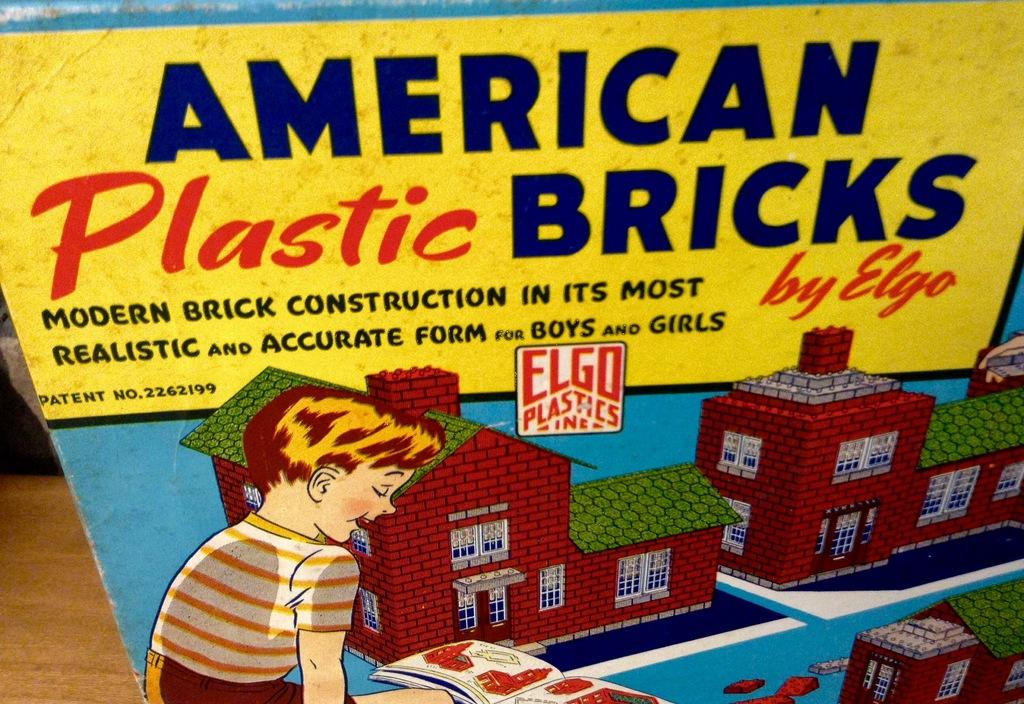What is the main subject of the image? There is a depiction of a boy in the image. What else can be seen in the image besides the boy? There are depictions of buildings in the image. Is there any text present in the image? Yes, there is text written in the image. How many chickens are depicted in the image? There are no chickens present in the image. What type of operation is being performed on the boy in the image? There is no operation being performed on the boy in the image; it is a depiction of a boy and buildings. 